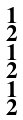<formula> <loc_0><loc_0><loc_500><loc_500>\begin{smallmatrix} 1 \\ 2 \\ 1 \\ 2 \\ 1 \\ 2 \end{smallmatrix}</formula> 